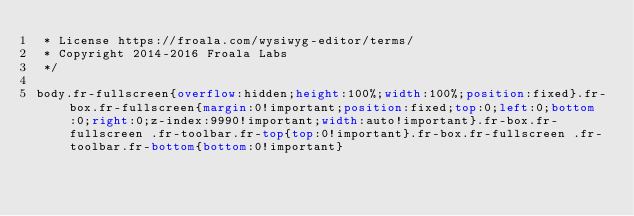<code> <loc_0><loc_0><loc_500><loc_500><_CSS_> * License https://froala.com/wysiwyg-editor/terms/
 * Copyright 2014-2016 Froala Labs
 */

body.fr-fullscreen{overflow:hidden;height:100%;width:100%;position:fixed}.fr-box.fr-fullscreen{margin:0!important;position:fixed;top:0;left:0;bottom:0;right:0;z-index:9990!important;width:auto!important}.fr-box.fr-fullscreen .fr-toolbar.fr-top{top:0!important}.fr-box.fr-fullscreen .fr-toolbar.fr-bottom{bottom:0!important}</code> 